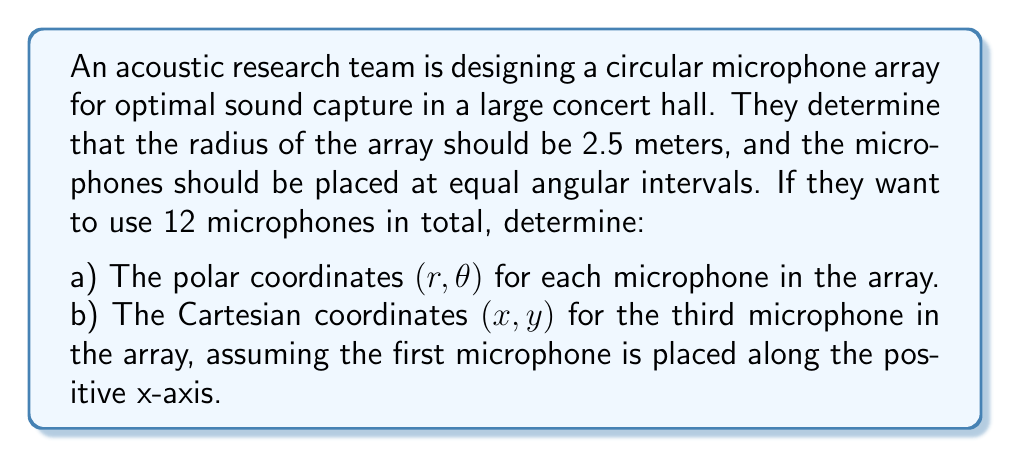Give your solution to this math problem. Let's approach this problem step-by-step:

1) For part a), we need to determine the polar coordinates $(r, \theta)$ for each microphone:

   - The radius $r$ is given as 2.5 meters for all microphones.
   - For the angle $\theta$, we need to divide the full circle (360° or $2\pi$ radians) by the number of microphones:
     $$\Delta\theta = \frac{2\pi}{12} = \frac{\pi}{6} \approx 0.5236 \text{ radians} \approx 30°$$

   So, the polar coordinates for the $n$-th microphone (where $n$ goes from 0 to 11) will be:

   $$(r, \theta) = \left(2.5, \frac{n\pi}{6}\right)$$

2) For part b), we need to convert the polar coordinates of the third microphone to Cartesian coordinates:

   - The third microphone corresponds to $n = 2$ (since we start counting from 0).
   - Its polar coordinates are $\left(2.5, \frac{2\pi}{6}\right) = \left(2.5, \frac{\pi}{3}\right)$

   To convert from polar to Cartesian coordinates, we use these formulas:
   $$x = r \cos(\theta)$$
   $$y = r \sin(\theta)$$

   Substituting our values:
   $$x = 2.5 \cos\left(\frac{\pi}{3}\right) = 2.5 \cdot \frac{1}{2} = 1.25$$
   $$y = 2.5 \sin\left(\frac{\pi}{3}\right) = 2.5 \cdot \frac{\sqrt{3}}{2} = \frac{5\sqrt{3}}{4} \approx 2.165$$
Answer: a) The polar coordinates for each microphone are $(2.5, \frac{n\pi}{6})$, where $n = 0, 1, 2, ..., 11$.

b) The Cartesian coordinates of the third microphone are $(1.25, \frac{5\sqrt{3}}{4})$ or approximately $(1.25, 2.165)$. 